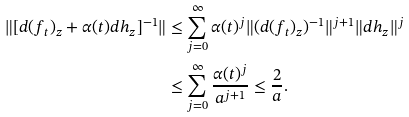Convert formula to latex. <formula><loc_0><loc_0><loc_500><loc_500>\| [ d ( f _ { t } ) _ { z } + \alpha ( t ) d h _ { z } ] ^ { - 1 } \| & \leq \sum _ { j = 0 } ^ { \infty } \alpha ( t ) ^ { j } \| ( d ( f _ { t } ) _ { z } ) ^ { - 1 } \| ^ { j + 1 } \| d h _ { z } \| ^ { j } \\ & \leq \sum _ { j = 0 } ^ { \infty } \frac { \alpha ( t ) ^ { j } } { a ^ { j + 1 } } \leq \frac { 2 } { a } .</formula> 